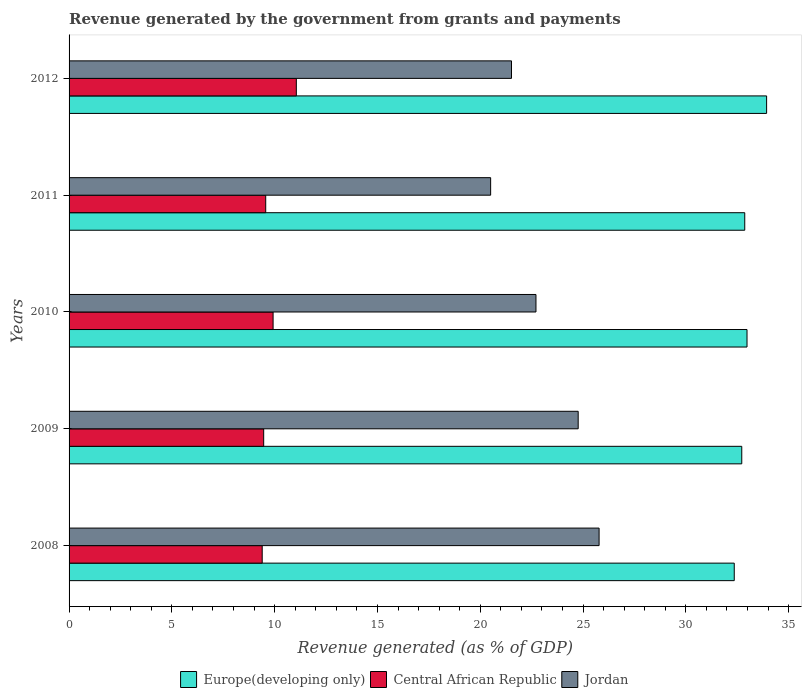Are the number of bars per tick equal to the number of legend labels?
Keep it short and to the point. Yes. Are the number of bars on each tick of the Y-axis equal?
Provide a short and direct response. Yes. What is the label of the 2nd group of bars from the top?
Offer a terse response. 2011. What is the revenue generated by the government in Jordan in 2008?
Offer a terse response. 25.78. Across all years, what is the maximum revenue generated by the government in Central African Republic?
Offer a terse response. 11.05. Across all years, what is the minimum revenue generated by the government in Europe(developing only)?
Ensure brevity in your answer.  32.35. In which year was the revenue generated by the government in Jordan maximum?
Make the answer very short. 2008. What is the total revenue generated by the government in Central African Republic in the graph?
Provide a short and direct response. 49.4. What is the difference between the revenue generated by the government in Jordan in 2008 and that in 2012?
Keep it short and to the point. 4.26. What is the difference between the revenue generated by the government in Jordan in 2010 and the revenue generated by the government in Europe(developing only) in 2012?
Offer a very short reply. -11.22. What is the average revenue generated by the government in Central African Republic per year?
Your answer should be very brief. 9.88. In the year 2012, what is the difference between the revenue generated by the government in Europe(developing only) and revenue generated by the government in Jordan?
Make the answer very short. 12.41. What is the ratio of the revenue generated by the government in Europe(developing only) in 2010 to that in 2011?
Your answer should be very brief. 1. Is the revenue generated by the government in Central African Republic in 2009 less than that in 2011?
Keep it short and to the point. Yes. Is the difference between the revenue generated by the government in Europe(developing only) in 2011 and 2012 greater than the difference between the revenue generated by the government in Jordan in 2011 and 2012?
Make the answer very short. No. What is the difference between the highest and the second highest revenue generated by the government in Jordan?
Give a very brief answer. 1.02. What is the difference between the highest and the lowest revenue generated by the government in Europe(developing only)?
Give a very brief answer. 1.57. In how many years, is the revenue generated by the government in Jordan greater than the average revenue generated by the government in Jordan taken over all years?
Offer a very short reply. 2. What does the 2nd bar from the top in 2008 represents?
Ensure brevity in your answer.  Central African Republic. What does the 2nd bar from the bottom in 2010 represents?
Provide a short and direct response. Central African Republic. How many bars are there?
Your response must be concise. 15. How many years are there in the graph?
Keep it short and to the point. 5. What is the difference between two consecutive major ticks on the X-axis?
Give a very brief answer. 5. What is the title of the graph?
Provide a succinct answer. Revenue generated by the government from grants and payments. What is the label or title of the X-axis?
Make the answer very short. Revenue generated (as % of GDP). What is the Revenue generated (as % of GDP) of Europe(developing only) in 2008?
Keep it short and to the point. 32.35. What is the Revenue generated (as % of GDP) of Central African Republic in 2008?
Offer a terse response. 9.39. What is the Revenue generated (as % of GDP) in Jordan in 2008?
Your answer should be very brief. 25.78. What is the Revenue generated (as % of GDP) in Europe(developing only) in 2009?
Your response must be concise. 32.72. What is the Revenue generated (as % of GDP) of Central African Republic in 2009?
Offer a terse response. 9.47. What is the Revenue generated (as % of GDP) in Jordan in 2009?
Ensure brevity in your answer.  24.76. What is the Revenue generated (as % of GDP) of Europe(developing only) in 2010?
Your answer should be compact. 32.98. What is the Revenue generated (as % of GDP) of Central African Republic in 2010?
Your answer should be very brief. 9.92. What is the Revenue generated (as % of GDP) of Jordan in 2010?
Your response must be concise. 22.71. What is the Revenue generated (as % of GDP) in Europe(developing only) in 2011?
Your answer should be very brief. 32.87. What is the Revenue generated (as % of GDP) of Central African Republic in 2011?
Offer a terse response. 9.56. What is the Revenue generated (as % of GDP) of Jordan in 2011?
Ensure brevity in your answer.  20.51. What is the Revenue generated (as % of GDP) of Europe(developing only) in 2012?
Offer a terse response. 33.93. What is the Revenue generated (as % of GDP) in Central African Republic in 2012?
Your response must be concise. 11.05. What is the Revenue generated (as % of GDP) of Jordan in 2012?
Offer a very short reply. 21.52. Across all years, what is the maximum Revenue generated (as % of GDP) in Europe(developing only)?
Ensure brevity in your answer.  33.93. Across all years, what is the maximum Revenue generated (as % of GDP) in Central African Republic?
Your answer should be very brief. 11.05. Across all years, what is the maximum Revenue generated (as % of GDP) of Jordan?
Your answer should be compact. 25.78. Across all years, what is the minimum Revenue generated (as % of GDP) of Europe(developing only)?
Keep it short and to the point. 32.35. Across all years, what is the minimum Revenue generated (as % of GDP) in Central African Republic?
Your answer should be very brief. 9.39. Across all years, what is the minimum Revenue generated (as % of GDP) in Jordan?
Make the answer very short. 20.51. What is the total Revenue generated (as % of GDP) of Europe(developing only) in the graph?
Ensure brevity in your answer.  164.85. What is the total Revenue generated (as % of GDP) of Central African Republic in the graph?
Give a very brief answer. 49.4. What is the total Revenue generated (as % of GDP) of Jordan in the graph?
Provide a succinct answer. 115.28. What is the difference between the Revenue generated (as % of GDP) in Europe(developing only) in 2008 and that in 2009?
Keep it short and to the point. -0.37. What is the difference between the Revenue generated (as % of GDP) of Central African Republic in 2008 and that in 2009?
Give a very brief answer. -0.07. What is the difference between the Revenue generated (as % of GDP) of Europe(developing only) in 2008 and that in 2010?
Your answer should be very brief. -0.62. What is the difference between the Revenue generated (as % of GDP) of Central African Republic in 2008 and that in 2010?
Provide a short and direct response. -0.53. What is the difference between the Revenue generated (as % of GDP) of Jordan in 2008 and that in 2010?
Offer a terse response. 3.07. What is the difference between the Revenue generated (as % of GDP) of Europe(developing only) in 2008 and that in 2011?
Give a very brief answer. -0.51. What is the difference between the Revenue generated (as % of GDP) of Central African Republic in 2008 and that in 2011?
Ensure brevity in your answer.  -0.17. What is the difference between the Revenue generated (as % of GDP) in Jordan in 2008 and that in 2011?
Offer a terse response. 5.27. What is the difference between the Revenue generated (as % of GDP) of Europe(developing only) in 2008 and that in 2012?
Offer a very short reply. -1.57. What is the difference between the Revenue generated (as % of GDP) in Central African Republic in 2008 and that in 2012?
Your response must be concise. -1.66. What is the difference between the Revenue generated (as % of GDP) in Jordan in 2008 and that in 2012?
Ensure brevity in your answer.  4.26. What is the difference between the Revenue generated (as % of GDP) of Europe(developing only) in 2009 and that in 2010?
Offer a very short reply. -0.26. What is the difference between the Revenue generated (as % of GDP) in Central African Republic in 2009 and that in 2010?
Keep it short and to the point. -0.46. What is the difference between the Revenue generated (as % of GDP) in Jordan in 2009 and that in 2010?
Give a very brief answer. 2.05. What is the difference between the Revenue generated (as % of GDP) of Europe(developing only) in 2009 and that in 2011?
Provide a short and direct response. -0.15. What is the difference between the Revenue generated (as % of GDP) of Central African Republic in 2009 and that in 2011?
Give a very brief answer. -0.1. What is the difference between the Revenue generated (as % of GDP) of Jordan in 2009 and that in 2011?
Your answer should be compact. 4.26. What is the difference between the Revenue generated (as % of GDP) of Europe(developing only) in 2009 and that in 2012?
Your response must be concise. -1.21. What is the difference between the Revenue generated (as % of GDP) in Central African Republic in 2009 and that in 2012?
Give a very brief answer. -1.59. What is the difference between the Revenue generated (as % of GDP) in Jordan in 2009 and that in 2012?
Provide a short and direct response. 3.24. What is the difference between the Revenue generated (as % of GDP) in Europe(developing only) in 2010 and that in 2011?
Provide a succinct answer. 0.11. What is the difference between the Revenue generated (as % of GDP) of Central African Republic in 2010 and that in 2011?
Your answer should be compact. 0.36. What is the difference between the Revenue generated (as % of GDP) of Jordan in 2010 and that in 2011?
Keep it short and to the point. 2.2. What is the difference between the Revenue generated (as % of GDP) in Europe(developing only) in 2010 and that in 2012?
Keep it short and to the point. -0.95. What is the difference between the Revenue generated (as % of GDP) in Central African Republic in 2010 and that in 2012?
Your response must be concise. -1.13. What is the difference between the Revenue generated (as % of GDP) in Jordan in 2010 and that in 2012?
Your answer should be very brief. 1.19. What is the difference between the Revenue generated (as % of GDP) of Europe(developing only) in 2011 and that in 2012?
Give a very brief answer. -1.06. What is the difference between the Revenue generated (as % of GDP) in Central African Republic in 2011 and that in 2012?
Offer a terse response. -1.49. What is the difference between the Revenue generated (as % of GDP) in Jordan in 2011 and that in 2012?
Offer a terse response. -1.01. What is the difference between the Revenue generated (as % of GDP) of Europe(developing only) in 2008 and the Revenue generated (as % of GDP) of Central African Republic in 2009?
Your answer should be compact. 22.89. What is the difference between the Revenue generated (as % of GDP) of Europe(developing only) in 2008 and the Revenue generated (as % of GDP) of Jordan in 2009?
Your answer should be very brief. 7.59. What is the difference between the Revenue generated (as % of GDP) of Central African Republic in 2008 and the Revenue generated (as % of GDP) of Jordan in 2009?
Your answer should be compact. -15.37. What is the difference between the Revenue generated (as % of GDP) of Europe(developing only) in 2008 and the Revenue generated (as % of GDP) of Central African Republic in 2010?
Offer a very short reply. 22.43. What is the difference between the Revenue generated (as % of GDP) of Europe(developing only) in 2008 and the Revenue generated (as % of GDP) of Jordan in 2010?
Offer a terse response. 9.64. What is the difference between the Revenue generated (as % of GDP) in Central African Republic in 2008 and the Revenue generated (as % of GDP) in Jordan in 2010?
Your response must be concise. -13.32. What is the difference between the Revenue generated (as % of GDP) of Europe(developing only) in 2008 and the Revenue generated (as % of GDP) of Central African Republic in 2011?
Keep it short and to the point. 22.79. What is the difference between the Revenue generated (as % of GDP) in Europe(developing only) in 2008 and the Revenue generated (as % of GDP) in Jordan in 2011?
Your response must be concise. 11.85. What is the difference between the Revenue generated (as % of GDP) of Central African Republic in 2008 and the Revenue generated (as % of GDP) of Jordan in 2011?
Give a very brief answer. -11.11. What is the difference between the Revenue generated (as % of GDP) in Europe(developing only) in 2008 and the Revenue generated (as % of GDP) in Central African Republic in 2012?
Your answer should be very brief. 21.3. What is the difference between the Revenue generated (as % of GDP) in Europe(developing only) in 2008 and the Revenue generated (as % of GDP) in Jordan in 2012?
Your answer should be compact. 10.83. What is the difference between the Revenue generated (as % of GDP) of Central African Republic in 2008 and the Revenue generated (as % of GDP) of Jordan in 2012?
Provide a succinct answer. -12.13. What is the difference between the Revenue generated (as % of GDP) of Europe(developing only) in 2009 and the Revenue generated (as % of GDP) of Central African Republic in 2010?
Offer a very short reply. 22.8. What is the difference between the Revenue generated (as % of GDP) of Europe(developing only) in 2009 and the Revenue generated (as % of GDP) of Jordan in 2010?
Provide a short and direct response. 10.01. What is the difference between the Revenue generated (as % of GDP) in Central African Republic in 2009 and the Revenue generated (as % of GDP) in Jordan in 2010?
Keep it short and to the point. -13.24. What is the difference between the Revenue generated (as % of GDP) in Europe(developing only) in 2009 and the Revenue generated (as % of GDP) in Central African Republic in 2011?
Give a very brief answer. 23.16. What is the difference between the Revenue generated (as % of GDP) of Europe(developing only) in 2009 and the Revenue generated (as % of GDP) of Jordan in 2011?
Offer a terse response. 12.21. What is the difference between the Revenue generated (as % of GDP) of Central African Republic in 2009 and the Revenue generated (as % of GDP) of Jordan in 2011?
Offer a very short reply. -11.04. What is the difference between the Revenue generated (as % of GDP) in Europe(developing only) in 2009 and the Revenue generated (as % of GDP) in Central African Republic in 2012?
Give a very brief answer. 21.67. What is the difference between the Revenue generated (as % of GDP) in Europe(developing only) in 2009 and the Revenue generated (as % of GDP) in Jordan in 2012?
Your answer should be very brief. 11.2. What is the difference between the Revenue generated (as % of GDP) in Central African Republic in 2009 and the Revenue generated (as % of GDP) in Jordan in 2012?
Provide a succinct answer. -12.05. What is the difference between the Revenue generated (as % of GDP) in Europe(developing only) in 2010 and the Revenue generated (as % of GDP) in Central African Republic in 2011?
Your answer should be very brief. 23.41. What is the difference between the Revenue generated (as % of GDP) in Europe(developing only) in 2010 and the Revenue generated (as % of GDP) in Jordan in 2011?
Give a very brief answer. 12.47. What is the difference between the Revenue generated (as % of GDP) of Central African Republic in 2010 and the Revenue generated (as % of GDP) of Jordan in 2011?
Keep it short and to the point. -10.58. What is the difference between the Revenue generated (as % of GDP) of Europe(developing only) in 2010 and the Revenue generated (as % of GDP) of Central African Republic in 2012?
Provide a succinct answer. 21.92. What is the difference between the Revenue generated (as % of GDP) of Europe(developing only) in 2010 and the Revenue generated (as % of GDP) of Jordan in 2012?
Ensure brevity in your answer.  11.46. What is the difference between the Revenue generated (as % of GDP) in Central African Republic in 2010 and the Revenue generated (as % of GDP) in Jordan in 2012?
Offer a terse response. -11.6. What is the difference between the Revenue generated (as % of GDP) of Europe(developing only) in 2011 and the Revenue generated (as % of GDP) of Central African Republic in 2012?
Your answer should be very brief. 21.81. What is the difference between the Revenue generated (as % of GDP) in Europe(developing only) in 2011 and the Revenue generated (as % of GDP) in Jordan in 2012?
Your answer should be compact. 11.35. What is the difference between the Revenue generated (as % of GDP) of Central African Republic in 2011 and the Revenue generated (as % of GDP) of Jordan in 2012?
Your answer should be very brief. -11.96. What is the average Revenue generated (as % of GDP) in Europe(developing only) per year?
Keep it short and to the point. 32.97. What is the average Revenue generated (as % of GDP) of Central African Republic per year?
Offer a very short reply. 9.88. What is the average Revenue generated (as % of GDP) in Jordan per year?
Offer a terse response. 23.06. In the year 2008, what is the difference between the Revenue generated (as % of GDP) in Europe(developing only) and Revenue generated (as % of GDP) in Central African Republic?
Your answer should be very brief. 22.96. In the year 2008, what is the difference between the Revenue generated (as % of GDP) in Europe(developing only) and Revenue generated (as % of GDP) in Jordan?
Offer a very short reply. 6.57. In the year 2008, what is the difference between the Revenue generated (as % of GDP) in Central African Republic and Revenue generated (as % of GDP) in Jordan?
Provide a succinct answer. -16.39. In the year 2009, what is the difference between the Revenue generated (as % of GDP) of Europe(developing only) and Revenue generated (as % of GDP) of Central African Republic?
Ensure brevity in your answer.  23.25. In the year 2009, what is the difference between the Revenue generated (as % of GDP) of Europe(developing only) and Revenue generated (as % of GDP) of Jordan?
Offer a very short reply. 7.96. In the year 2009, what is the difference between the Revenue generated (as % of GDP) of Central African Republic and Revenue generated (as % of GDP) of Jordan?
Provide a short and direct response. -15.3. In the year 2010, what is the difference between the Revenue generated (as % of GDP) in Europe(developing only) and Revenue generated (as % of GDP) in Central African Republic?
Ensure brevity in your answer.  23.05. In the year 2010, what is the difference between the Revenue generated (as % of GDP) of Europe(developing only) and Revenue generated (as % of GDP) of Jordan?
Your answer should be compact. 10.27. In the year 2010, what is the difference between the Revenue generated (as % of GDP) in Central African Republic and Revenue generated (as % of GDP) in Jordan?
Your answer should be very brief. -12.79. In the year 2011, what is the difference between the Revenue generated (as % of GDP) of Europe(developing only) and Revenue generated (as % of GDP) of Central African Republic?
Offer a terse response. 23.3. In the year 2011, what is the difference between the Revenue generated (as % of GDP) in Europe(developing only) and Revenue generated (as % of GDP) in Jordan?
Provide a succinct answer. 12.36. In the year 2011, what is the difference between the Revenue generated (as % of GDP) of Central African Republic and Revenue generated (as % of GDP) of Jordan?
Offer a very short reply. -10.94. In the year 2012, what is the difference between the Revenue generated (as % of GDP) in Europe(developing only) and Revenue generated (as % of GDP) in Central African Republic?
Make the answer very short. 22.88. In the year 2012, what is the difference between the Revenue generated (as % of GDP) in Europe(developing only) and Revenue generated (as % of GDP) in Jordan?
Your answer should be compact. 12.41. In the year 2012, what is the difference between the Revenue generated (as % of GDP) in Central African Republic and Revenue generated (as % of GDP) in Jordan?
Offer a very short reply. -10.47. What is the ratio of the Revenue generated (as % of GDP) in Jordan in 2008 to that in 2009?
Your response must be concise. 1.04. What is the ratio of the Revenue generated (as % of GDP) in Europe(developing only) in 2008 to that in 2010?
Provide a short and direct response. 0.98. What is the ratio of the Revenue generated (as % of GDP) of Central African Republic in 2008 to that in 2010?
Your answer should be compact. 0.95. What is the ratio of the Revenue generated (as % of GDP) of Jordan in 2008 to that in 2010?
Provide a short and direct response. 1.14. What is the ratio of the Revenue generated (as % of GDP) of Europe(developing only) in 2008 to that in 2011?
Your answer should be compact. 0.98. What is the ratio of the Revenue generated (as % of GDP) in Central African Republic in 2008 to that in 2011?
Your answer should be compact. 0.98. What is the ratio of the Revenue generated (as % of GDP) in Jordan in 2008 to that in 2011?
Your response must be concise. 1.26. What is the ratio of the Revenue generated (as % of GDP) in Europe(developing only) in 2008 to that in 2012?
Keep it short and to the point. 0.95. What is the ratio of the Revenue generated (as % of GDP) in Central African Republic in 2008 to that in 2012?
Your answer should be very brief. 0.85. What is the ratio of the Revenue generated (as % of GDP) in Jordan in 2008 to that in 2012?
Keep it short and to the point. 1.2. What is the ratio of the Revenue generated (as % of GDP) of Central African Republic in 2009 to that in 2010?
Ensure brevity in your answer.  0.95. What is the ratio of the Revenue generated (as % of GDP) in Jordan in 2009 to that in 2010?
Give a very brief answer. 1.09. What is the ratio of the Revenue generated (as % of GDP) of Europe(developing only) in 2009 to that in 2011?
Your response must be concise. 1. What is the ratio of the Revenue generated (as % of GDP) of Jordan in 2009 to that in 2011?
Provide a short and direct response. 1.21. What is the ratio of the Revenue generated (as % of GDP) of Europe(developing only) in 2009 to that in 2012?
Give a very brief answer. 0.96. What is the ratio of the Revenue generated (as % of GDP) of Central African Republic in 2009 to that in 2012?
Provide a succinct answer. 0.86. What is the ratio of the Revenue generated (as % of GDP) in Jordan in 2009 to that in 2012?
Provide a short and direct response. 1.15. What is the ratio of the Revenue generated (as % of GDP) in Europe(developing only) in 2010 to that in 2011?
Offer a very short reply. 1. What is the ratio of the Revenue generated (as % of GDP) of Central African Republic in 2010 to that in 2011?
Offer a terse response. 1.04. What is the ratio of the Revenue generated (as % of GDP) in Jordan in 2010 to that in 2011?
Give a very brief answer. 1.11. What is the ratio of the Revenue generated (as % of GDP) of Europe(developing only) in 2010 to that in 2012?
Ensure brevity in your answer.  0.97. What is the ratio of the Revenue generated (as % of GDP) of Central African Republic in 2010 to that in 2012?
Offer a very short reply. 0.9. What is the ratio of the Revenue generated (as % of GDP) in Jordan in 2010 to that in 2012?
Keep it short and to the point. 1.06. What is the ratio of the Revenue generated (as % of GDP) in Europe(developing only) in 2011 to that in 2012?
Your answer should be compact. 0.97. What is the ratio of the Revenue generated (as % of GDP) of Central African Republic in 2011 to that in 2012?
Give a very brief answer. 0.87. What is the ratio of the Revenue generated (as % of GDP) of Jordan in 2011 to that in 2012?
Give a very brief answer. 0.95. What is the difference between the highest and the second highest Revenue generated (as % of GDP) in Europe(developing only)?
Provide a short and direct response. 0.95. What is the difference between the highest and the second highest Revenue generated (as % of GDP) in Central African Republic?
Give a very brief answer. 1.13. What is the difference between the highest and the second highest Revenue generated (as % of GDP) in Jordan?
Ensure brevity in your answer.  1.02. What is the difference between the highest and the lowest Revenue generated (as % of GDP) of Europe(developing only)?
Make the answer very short. 1.57. What is the difference between the highest and the lowest Revenue generated (as % of GDP) in Central African Republic?
Your response must be concise. 1.66. What is the difference between the highest and the lowest Revenue generated (as % of GDP) of Jordan?
Offer a terse response. 5.27. 